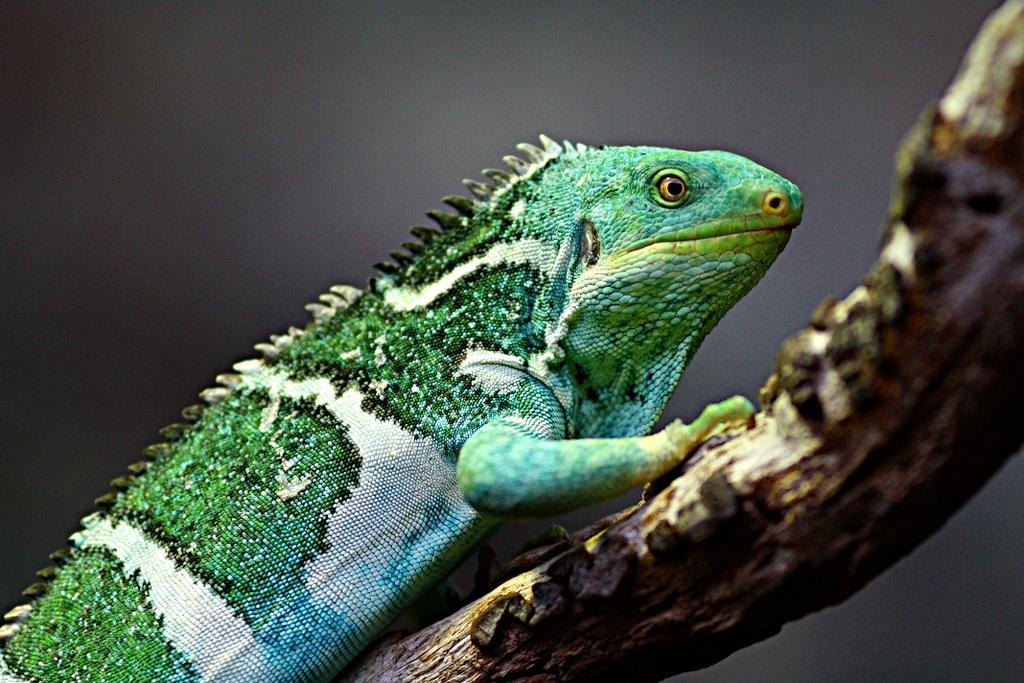What type of animal is in the image? There is a reptile in the image. Can you describe the background of the image? The background of the image is blurry. What type of card is being used to divide the reptile in the image? There is no card or division present in the image; it features a reptile with a blurry background. How is the hook attached to the reptile in the image? There is no hook present in the image; it features a reptile with a blurry background. 